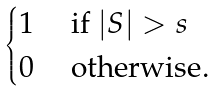Convert formula to latex. <formula><loc_0><loc_0><loc_500><loc_500>\begin{cases} 1 & \text { if } | S | > s \\ 0 & \text { otherwise} . \end{cases}</formula> 